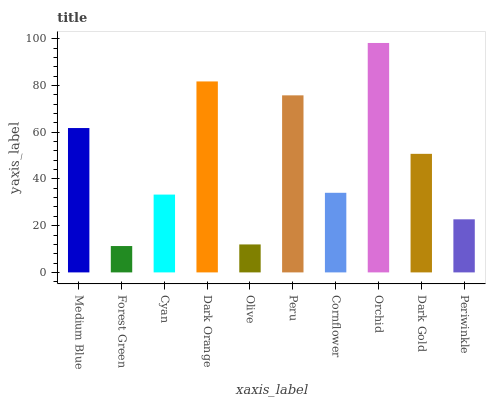Is Forest Green the minimum?
Answer yes or no. Yes. Is Orchid the maximum?
Answer yes or no. Yes. Is Cyan the minimum?
Answer yes or no. No. Is Cyan the maximum?
Answer yes or no. No. Is Cyan greater than Forest Green?
Answer yes or no. Yes. Is Forest Green less than Cyan?
Answer yes or no. Yes. Is Forest Green greater than Cyan?
Answer yes or no. No. Is Cyan less than Forest Green?
Answer yes or no. No. Is Dark Gold the high median?
Answer yes or no. Yes. Is Cornflower the low median?
Answer yes or no. Yes. Is Medium Blue the high median?
Answer yes or no. No. Is Cyan the low median?
Answer yes or no. No. 